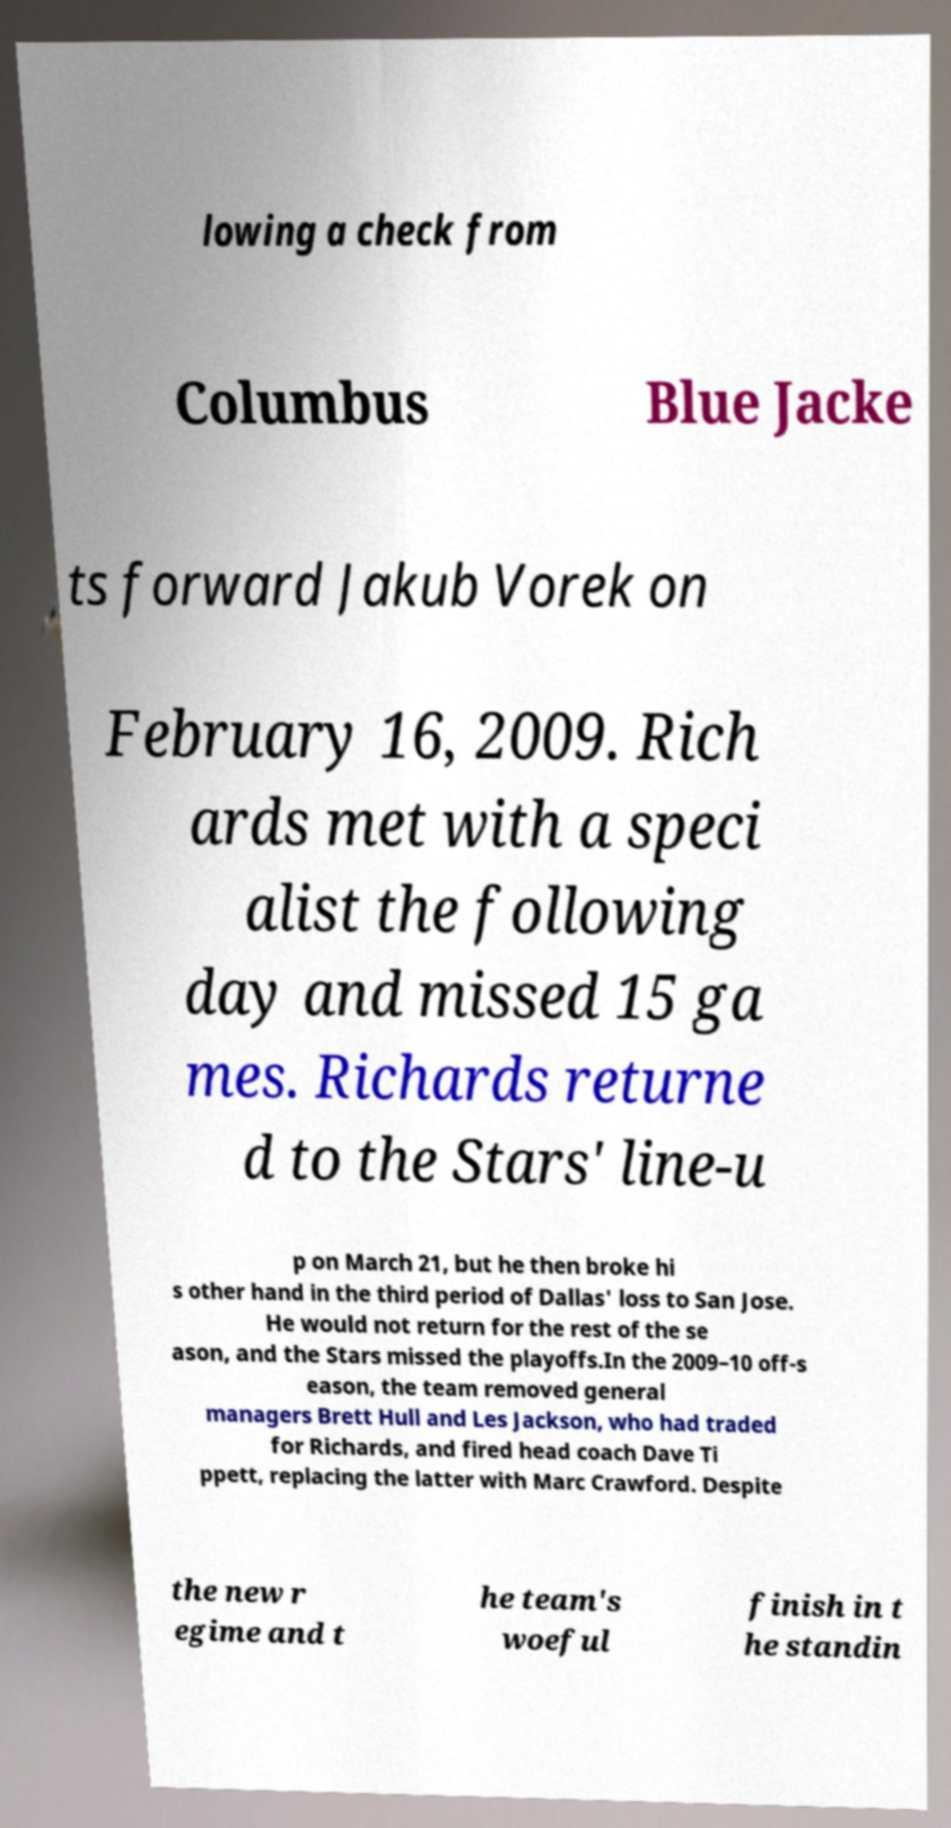Please read and relay the text visible in this image. What does it say? lowing a check from Columbus Blue Jacke ts forward Jakub Vorek on February 16, 2009. Rich ards met with a speci alist the following day and missed 15 ga mes. Richards returne d to the Stars' line-u p on March 21, but he then broke hi s other hand in the third period of Dallas' loss to San Jose. He would not return for the rest of the se ason, and the Stars missed the playoffs.In the 2009–10 off-s eason, the team removed general managers Brett Hull and Les Jackson, who had traded for Richards, and fired head coach Dave Ti ppett, replacing the latter with Marc Crawford. Despite the new r egime and t he team's woeful finish in t he standin 